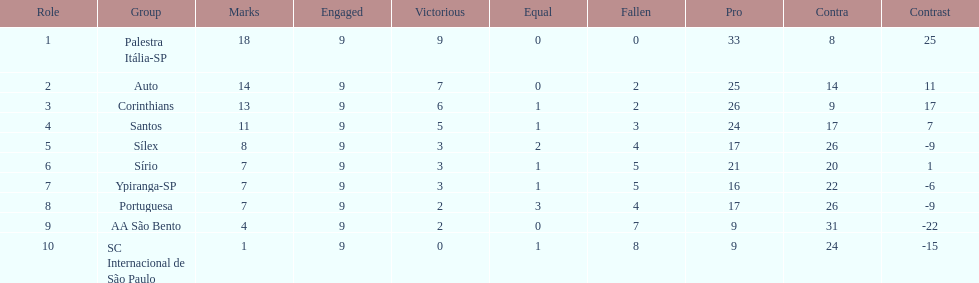Which team achieved the maximum points? Palestra Itália-SP. 